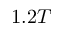Convert formula to latex. <formula><loc_0><loc_0><loc_500><loc_500>1 . 2 T</formula> 